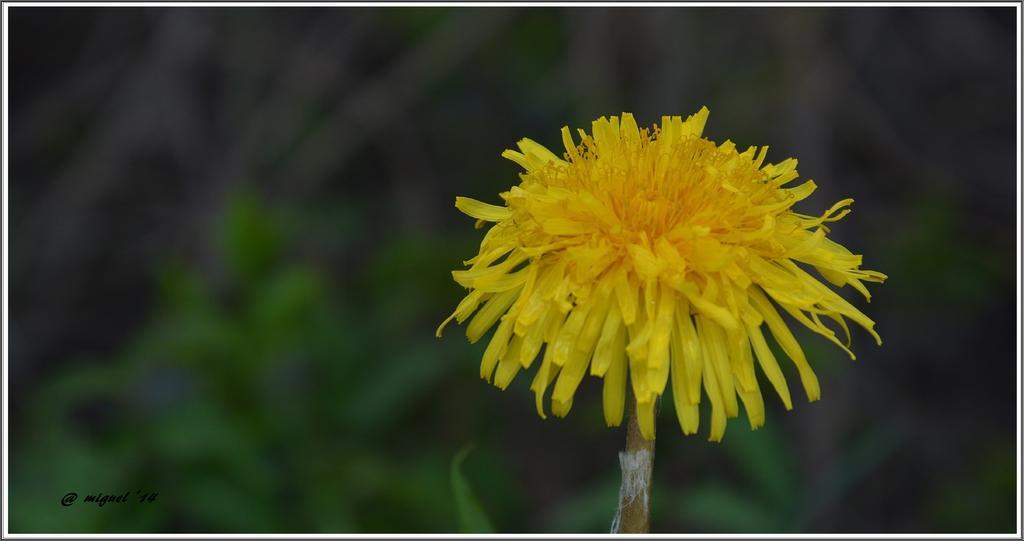Can you describe this image briefly? In this picture there is a yellow color flower on the right side of the image and the background area of the image is blur. 